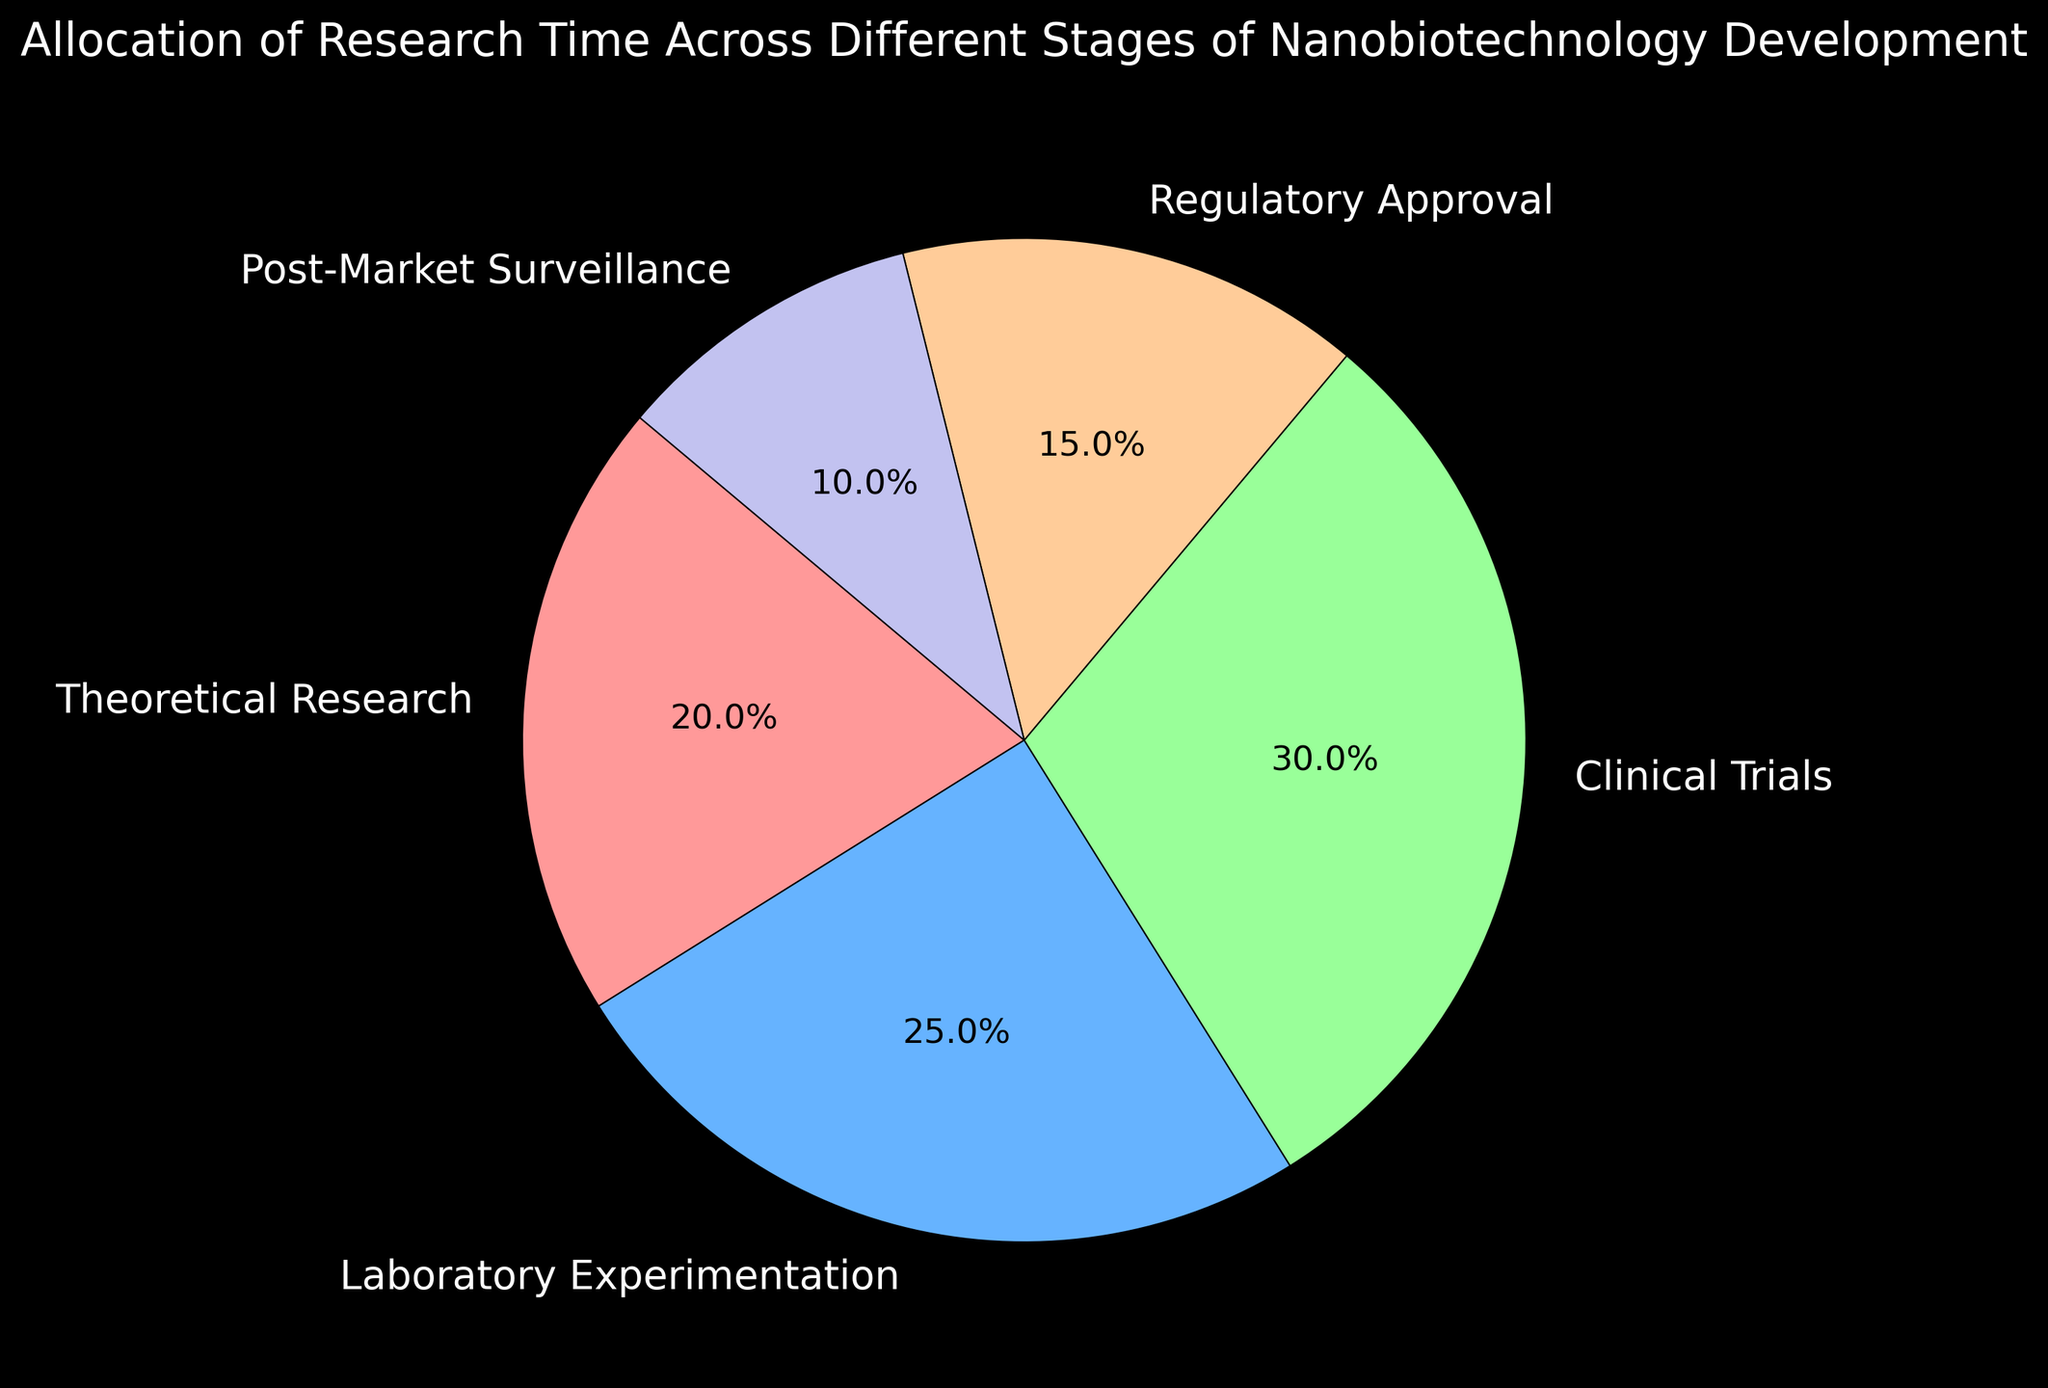What's the total time allocation percentage for Theoretical Research and Post-Market Surveillance combined? To find the combined time allocation percentage for Theoretical Research and Post-Market Surveillance, add their individual percentages: 20% (Theoretical Research) + 10% (Post-Market Surveillance) = 30%.
Answer: 30% Which stage has the highest time allocation percentage? To determine which stage has the highest time allocation percentage, look at the values for each stage in the pie chart. The Clinical Trials stage has the highest allocation at 30%.
Answer: Clinical Trials What is the difference in time allocation between Laboratory Experimentation and Regulatory Approval? To find the difference in time allocation between Laboratory Experimentation and Regulatory Approval, subtract the percentage of Regulatory Approval from Laboratory Experimentation: 25% (Laboratory Experimentation) - 15% (Regulatory Approval) = 10%.
Answer: 10% Are any stages allocated an equal amount of research time? Analyzing the percentages, we see that no two stages have the same time allocation percentage. Each stage has a unique value.
Answer: No Which stage is allocated the least amount of research time? To identify the stage with the least time allocation, look for the smallest percentage in the pie chart. Post-Market Surveillance has the smallest allocation at 10%.
Answer: Post-Market Surveillance What's the average time allocation percentage across all five stages? To calculate the average time allocation, sum all the percentages and divide by the number of stages: (20% + 25% + 30% + 15% + 10%) / 5 = 20%.
Answer: 20% What is the combined time allocation percentage for stages with less than 20% allocation? Identify the stages with less than 20% allocation (Regulatory Approval: 15% and Post-Market Surveillance: 10%), then add their percentages: 15% + 10% = 25%.
Answer: 25% How much more time is allocated to Clinical Trials compared to Post-Market Surveillance? Subtract the time allocation for Post-Market Surveillance from that for Clinical Trials: 30% (Clinical Trials) - 10% (Post-Market Surveillance) = 20%.
Answer: 20% What color represents the stage with 25% time allocation? In the pie chart, Laboratory Experimentation is represented in a shade of blue and has 25% time allocation. Thus, the color blue represents the stage with 25% allocation.
Answer: Blue 